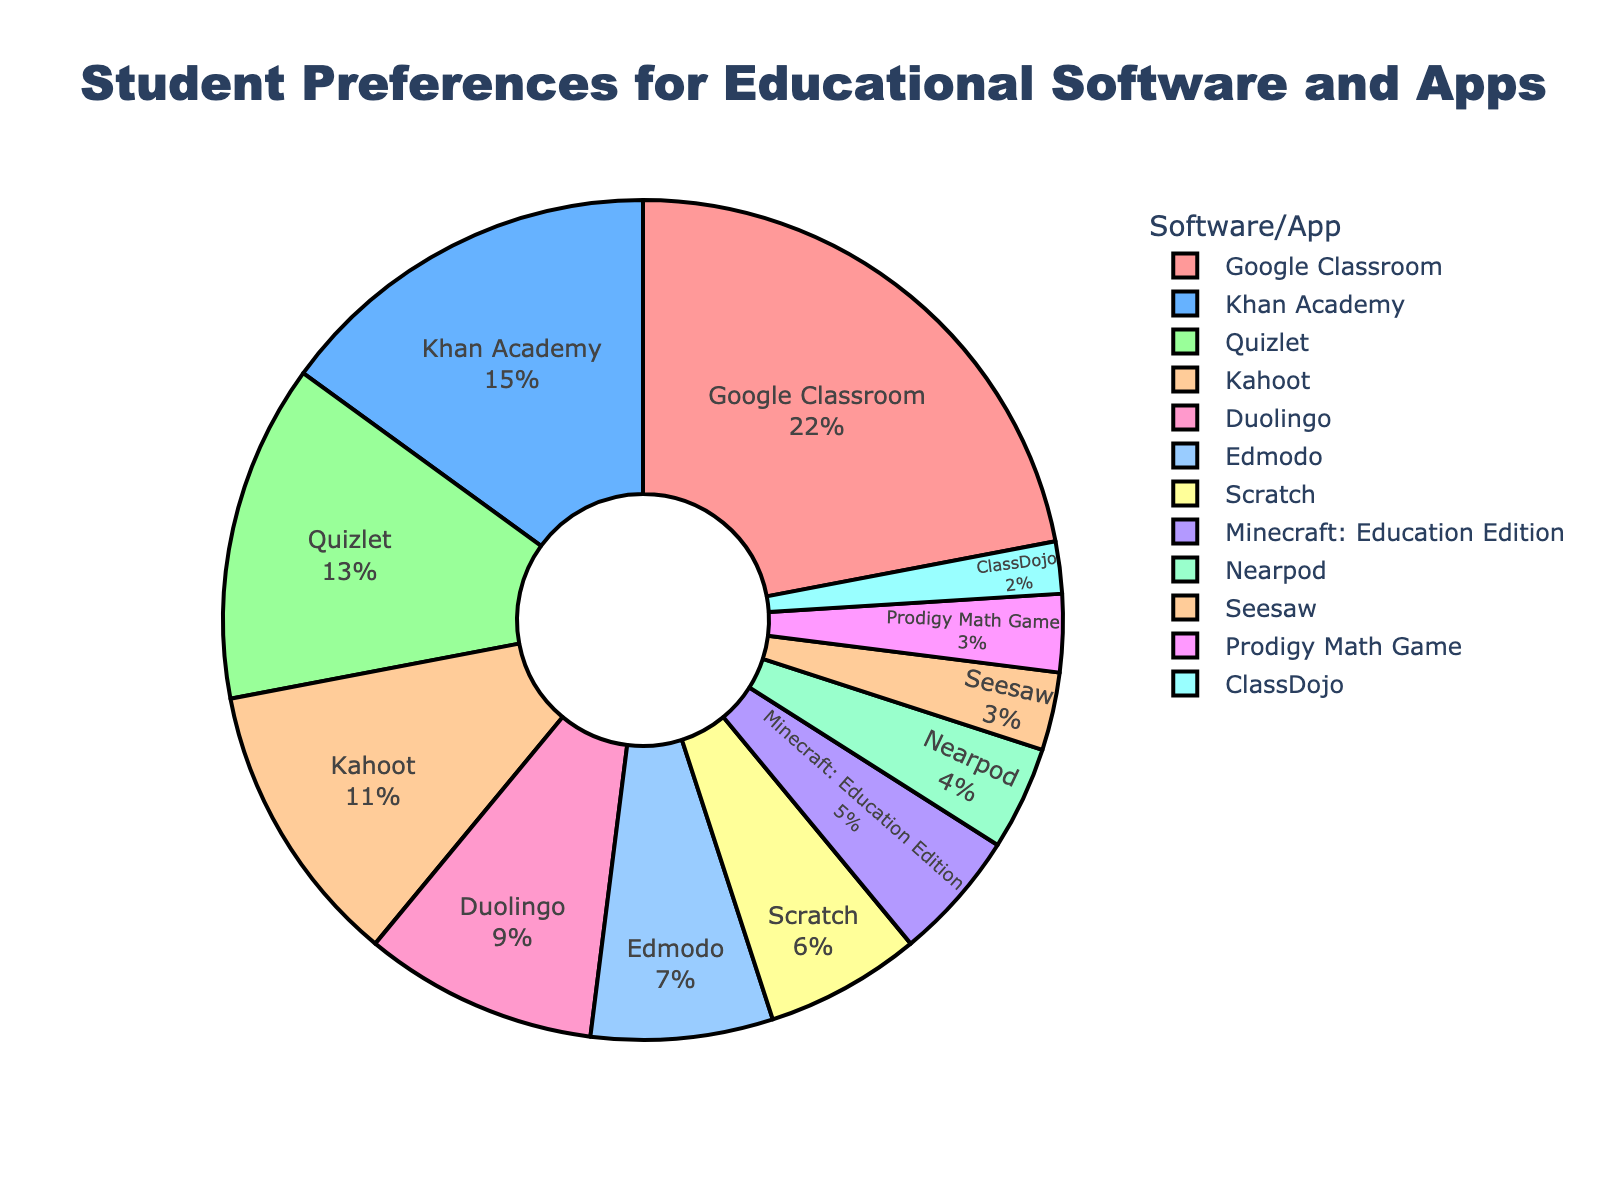what percentage of students prefer Google Classroom? The pie chart shows that the slice labeled “Google Classroom” corresponds to 22%.
Answer: 22% which software or app is the second most preferred among students? Referring to the pie chart, the second largest slice represents Khan Academy, corresponding to 15%.
Answer: Khan Academy how many educational apps or software have a preference rate of less than or equal to 5%? The pie chart indicates Minecraft: Education Edition (5%), Nearpod (4%), Seesaw (3%), Prodigy Math Game (3%), and ClassDojo (2%). There are five such apps.
Answer: 5 what's the combined percentage of students preferring Khan Academy and Quizlet? The pie chart shows 15% preference for Khan Academy and 13% for Quizlet. Combining these percentages: 15% + 13% = 28%.
Answer: 28% is the preference for Kahoot higher or lower than for Duolingo? From the pie chart, Kahoot has a preference of 11%, while Duolingo has 9%. Since 11% is greater than 9%, the preference for Kahoot is higher than for Duolingo.
Answer: Higher which app has the least student preference? Referring to the pie chart, the smallest slice corresponds to ClassDojo, with 2%.
Answer: ClassDojo how does the preference for Google Classroom compare to the sum of preferences for Duolingo and Scratch? Google Classroom has a 22% preference, while Duolingo is 9% and Scratch is 6%. Adding Duolingo and Scratch gives: 9% + 6% = 15%. Since 22% is greater than 15%, Google Classroom’s preference is higher.
Answer: Higher which app has a preference that is exactly double the preference of Scratch? Scratch has a preference of 6%. Doubling this gives 6% * 2 = 12%, but no app matches exactly.
Answer: None what's the combined preference percentage for apps preferred by less than 10% of students? Apps with less than 10% preference are Duolingo (9%), Edmodo (7%), Scratch (6%), Minecraft: Education Edition (5%), Nearpod (4%), Seesaw (3%), Prodigy Math Game (3%), and ClassDojo (2%). Adding these: 9% + 7% + 6% + 5% + 4% + 3% + 3% + 2% = 39%.
Answer: 39% how does the sum of the preferences for the top three apps compare to the total percentage of all other apps combined? The top three apps are Google Classroom (22%), Khan Academy (15%), and Quizlet (13%), giving a sum of 22% + 15% + 13% = 50%. The total preference for all apps is 100%, so the sum for the remaining apps is 100% - 50% = 50%. The sums are equal.
Answer: Equal 